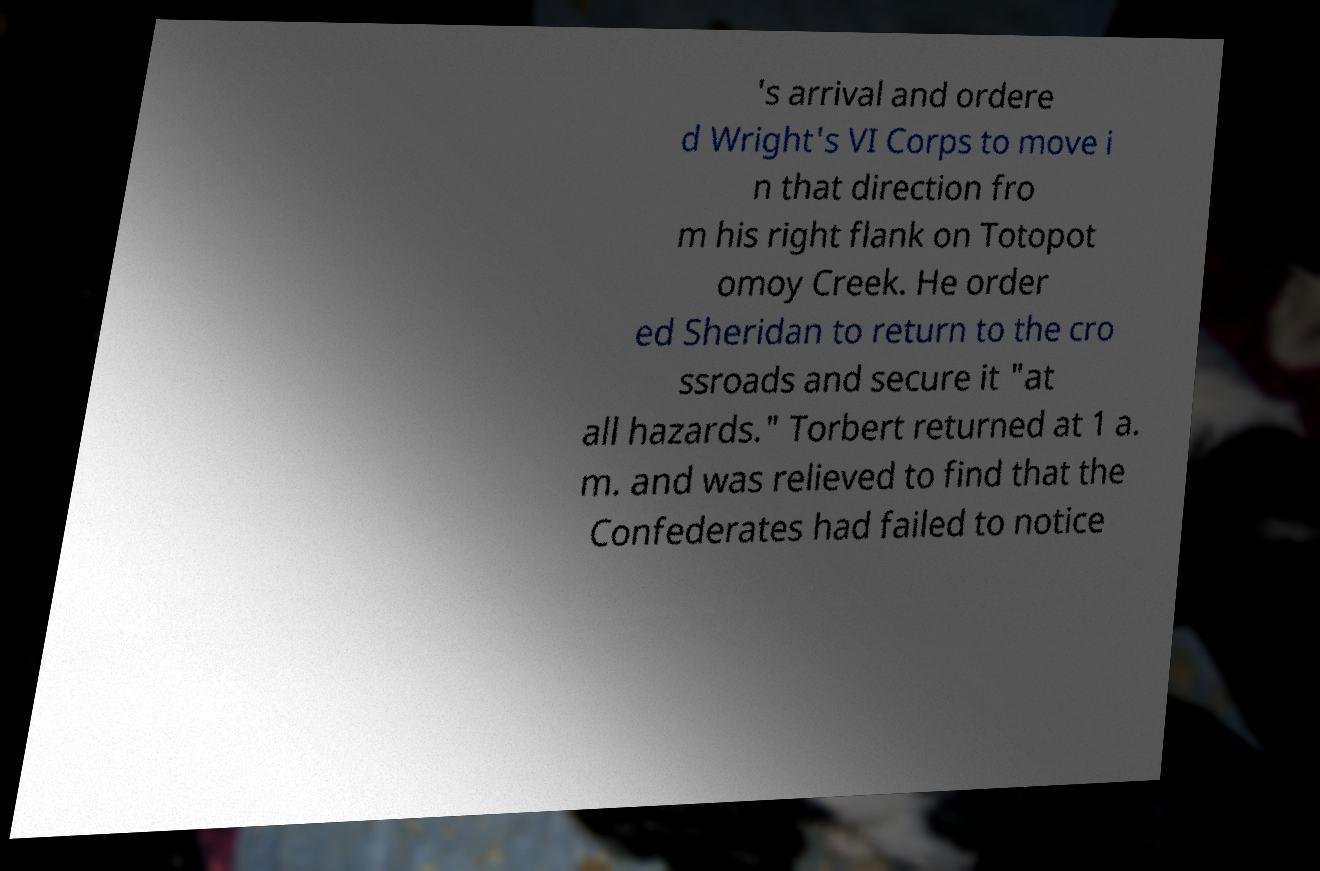Can you read and provide the text displayed in the image?This photo seems to have some interesting text. Can you extract and type it out for me? 's arrival and ordere d Wright's VI Corps to move i n that direction fro m his right flank on Totopot omoy Creek. He order ed Sheridan to return to the cro ssroads and secure it "at all hazards." Torbert returned at 1 a. m. and was relieved to find that the Confederates had failed to notice 